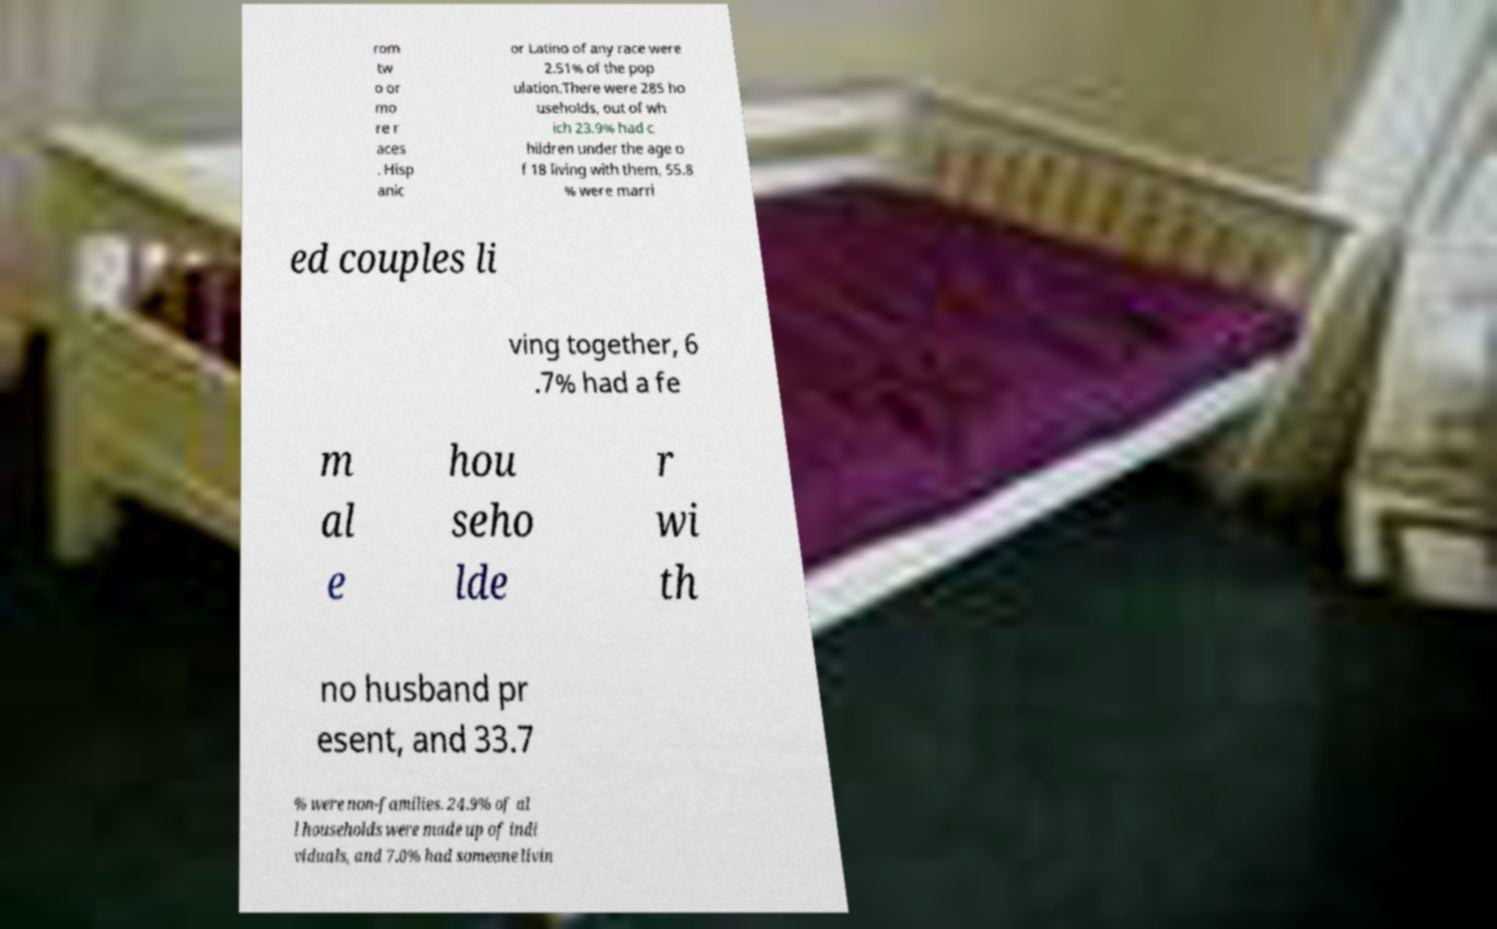Please identify and transcribe the text found in this image. rom tw o or mo re r aces . Hisp anic or Latino of any race were 2.51% of the pop ulation.There were 285 ho useholds, out of wh ich 23.9% had c hildren under the age o f 18 living with them, 55.8 % were marri ed couples li ving together, 6 .7% had a fe m al e hou seho lde r wi th no husband pr esent, and 33.7 % were non-families. 24.9% of al l households were made up of indi viduals, and 7.0% had someone livin 